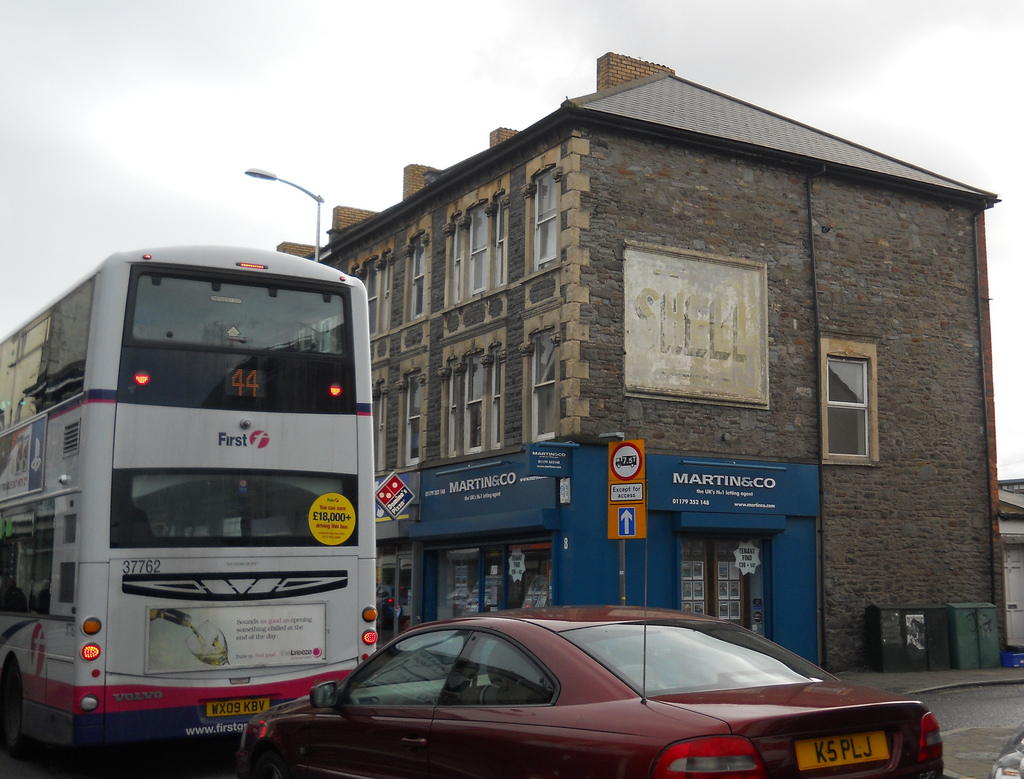Please provide the bounding box coordinate of the region this sentence describes: orange and white sign. The bounding box coordinate for the orange and white sign is approximately [0.59, 0.55, 0.63, 0.64]. This pinpoints the specific location of the colorful sign, offering a detailed reference for identification. 